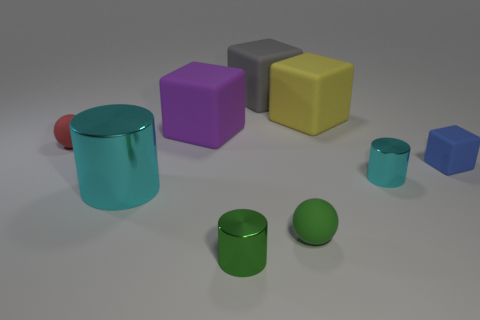Subtract 1 blocks. How many blocks are left? 3 Add 1 yellow cubes. How many objects exist? 10 Subtract all blocks. How many objects are left? 5 Add 7 green rubber spheres. How many green rubber spheres are left? 8 Add 8 tiny cyan shiny things. How many tiny cyan shiny things exist? 9 Subtract 1 red spheres. How many objects are left? 8 Subtract all large cyan metal cylinders. Subtract all small matte spheres. How many objects are left? 6 